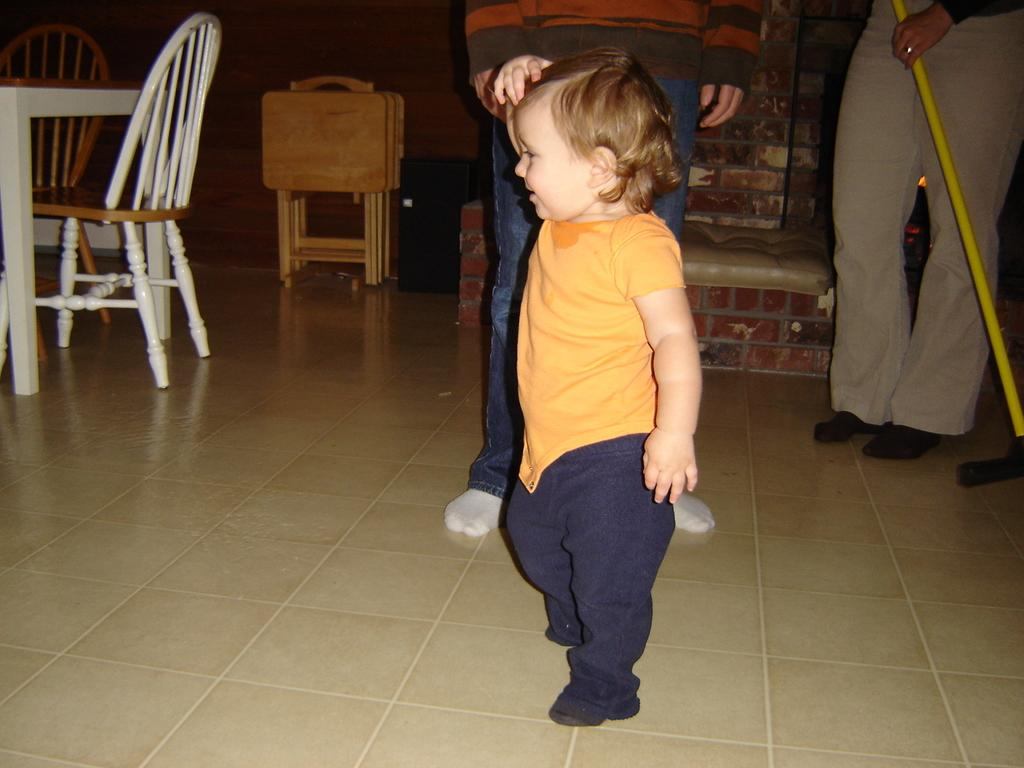What is the main subject of the image? There is a child in the image. Can you describe the people behind the child? There are persons behind the child. How many chairs are visible in the image? There are 2 chairs in the image. What furniture is present in the image besides the chairs? There is a table in the image. What type of background can be seen in the image? There is a wall visible in the image. What type of popcorn is being used as glue for the business meeting in the image? There is no popcorn, glue, or business meeting present in the image. 